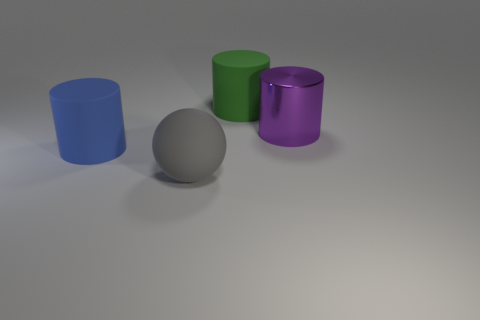Subtract all big matte cylinders. How many cylinders are left? 1 Add 4 small purple blocks. How many objects exist? 8 Subtract all spheres. How many objects are left? 3 Add 1 big purple objects. How many big purple objects exist? 2 Subtract 0 red blocks. How many objects are left? 4 Subtract all large green matte objects. Subtract all small metallic objects. How many objects are left? 3 Add 3 big blue rubber objects. How many big blue rubber objects are left? 4 